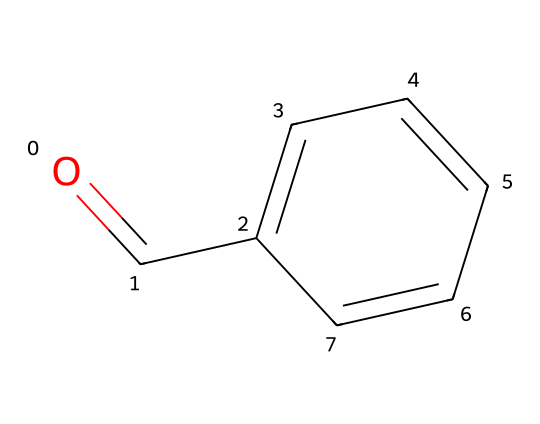What is the molecular formula of this compound? The SMILES representation O=Cc1ccccc1 indicates one carbonyl group (C=O) and a benzene ring (c1ccccc1) with six carbon atoms. Counting these, the total number of carbons is 7, with 6 hydrogens from the benzene and one from the carbonyl. Thus, the molecular formula is C7H6O.
Answer: C7H6O How many rings are present in this structure? The structure contains a benzene ring, which is a six-membered carbon ring. There are no additional rings present in the given SMILES.
Answer: 1 What functional group is present in this molecule? The presence of the carbonyl group (C=O) indicates that this molecule contains an aldehyde functional group. This can be identified from the O=C part of the SMILES.
Answer: aldehyde How many double bonds are present in the molecule? The carbonyl group accounts for one double bond (C=O) at the terminal carbon, while the benzene ring contributes alternating double bonds as part of its aromatic structure. However, these are not counted separately as they are part of the cyclic structure. Therefore, we identify a total of one significant double bond.
Answer: 1 What type of hybridization is present in the benzene ring? The carbon atoms in the benzene ring undergo sp2 hybridization due to the presence of one double bond between each pair of adjacent carbon atoms, allowing for planar structure and the delocalization of electrons.
Answer: sp2 Is this molecule polar or nonpolar? The presence of the polar carbonyl group (C=O) makes the overall molecule polar, as this group creates a dipole moment in the structure, despite the nonpolar character of the benzene ring.
Answer: polar 